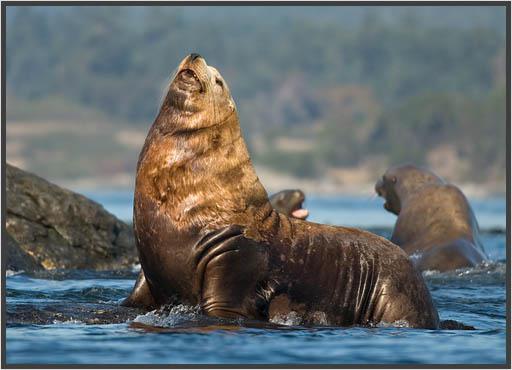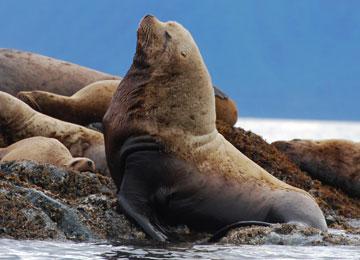The first image is the image on the left, the second image is the image on the right. For the images displayed, is the sentence "In each image, a large seal has its head and shoulders upright, and the upright seals in the left and right images face the same direction." factually correct? Answer yes or no. Yes. The first image is the image on the left, the second image is the image on the right. Examine the images to the left and right. Is the description "The left image contains exactly one sea lion." accurate? Answer yes or no. No. 